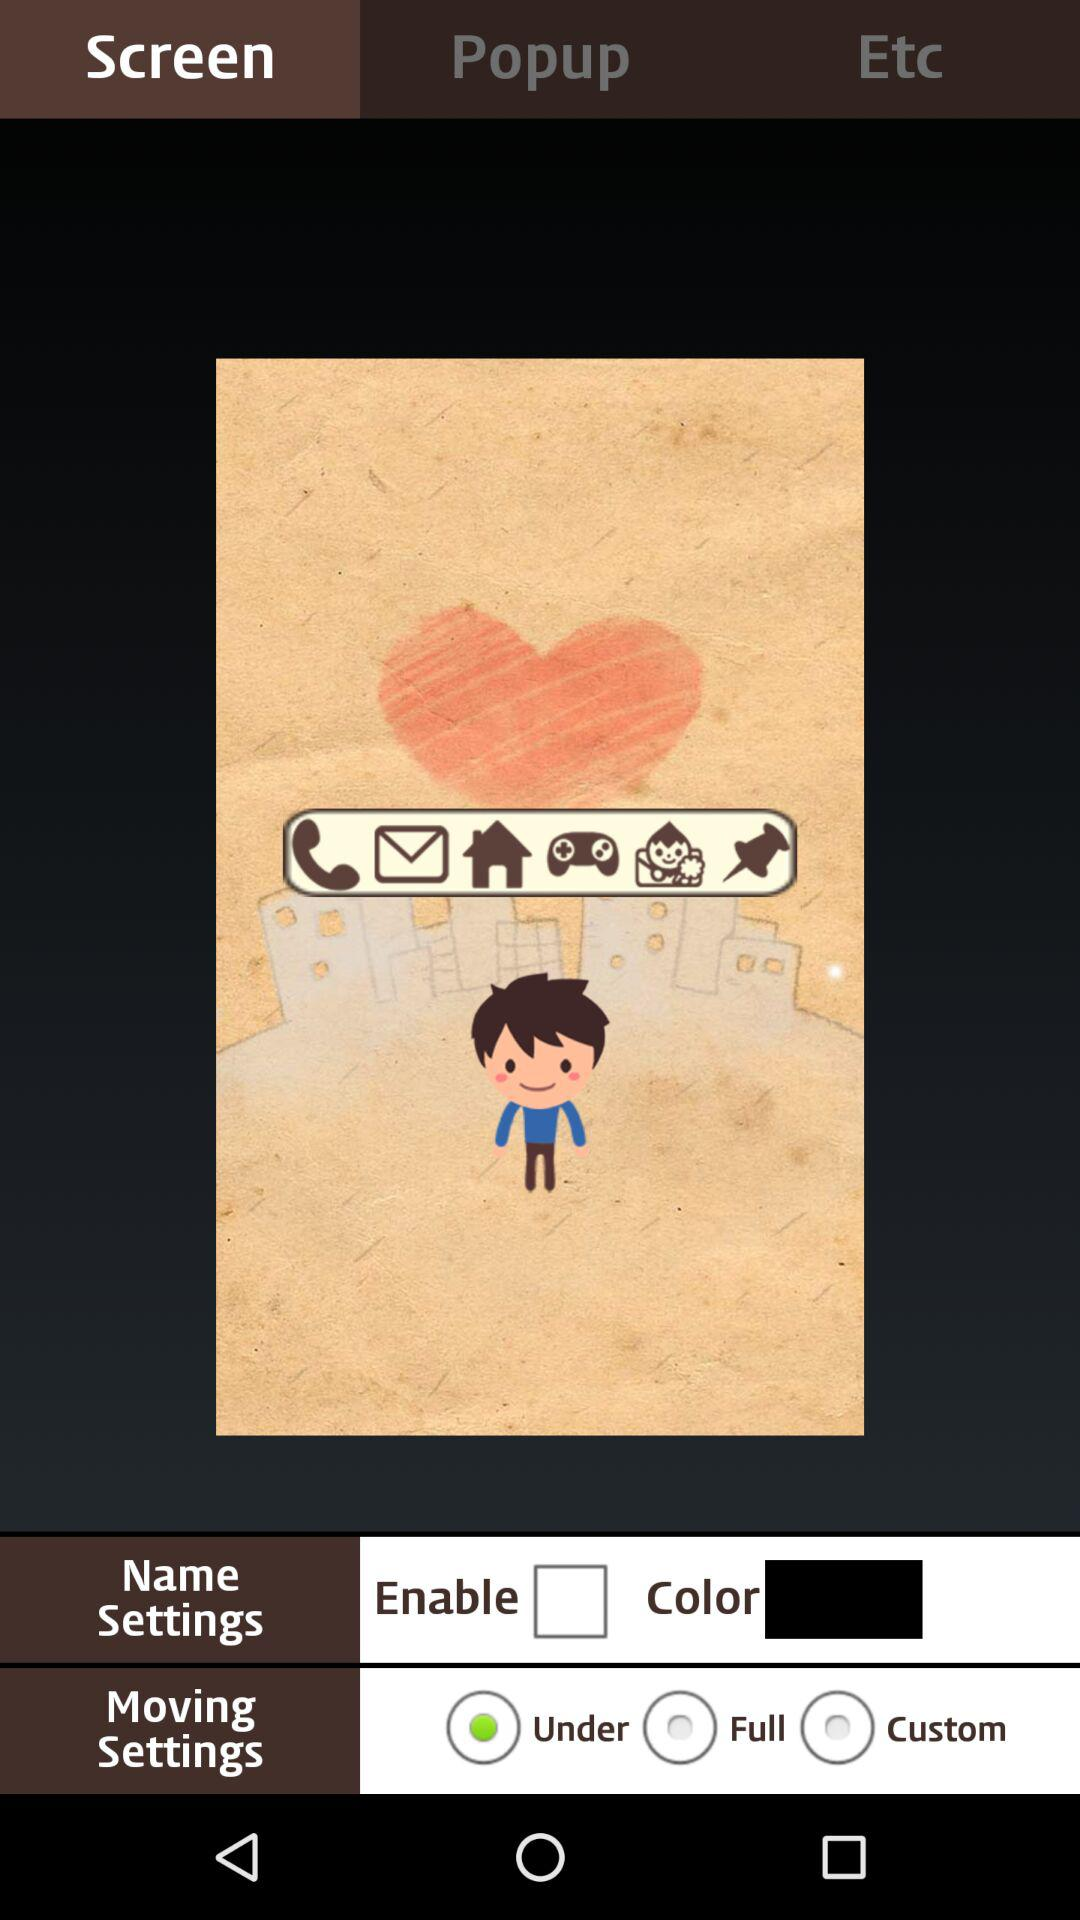What is the selected option for "Moving Settings"? The selected option for "Moving Settings" is "Under". 